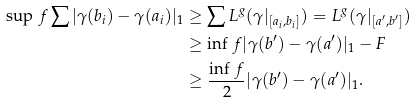<formula> <loc_0><loc_0><loc_500><loc_500>\sup \, f \sum | \gamma ( b _ { i } ) - \gamma ( a _ { i } ) | _ { 1 } & \geq \sum L ^ { g } ( \gamma | _ { [ a _ { i } , b _ { i } ] } ) = L ^ { g } ( \gamma | _ { [ a ^ { \prime } , b ^ { \prime } ] } ) \\ & \geq \inf \, f | \gamma ( b ^ { \prime } ) - \gamma ( a ^ { \prime } ) | _ { 1 } - F \\ & \geq \frac { \inf \, f } { 2 } | \gamma ( b ^ { \prime } ) - \gamma ( a ^ { \prime } ) | _ { 1 } .</formula> 